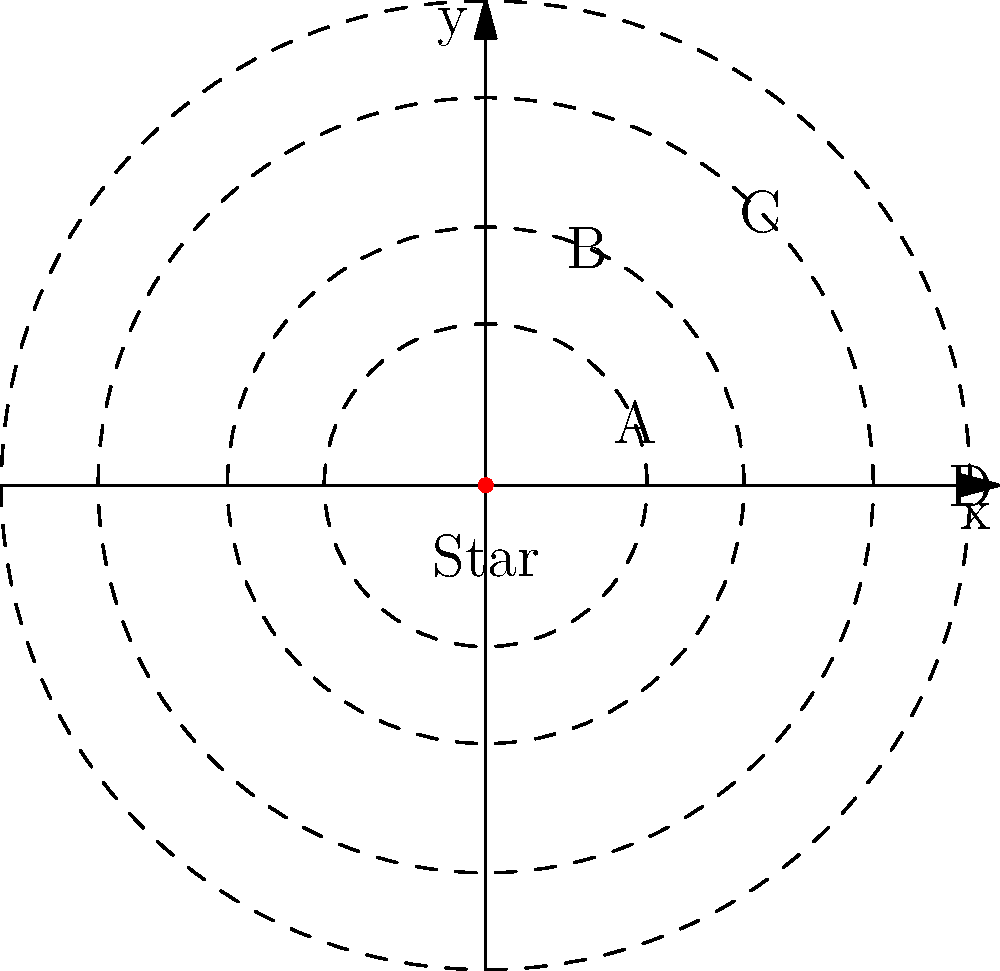In Ben Bova's fictional solar system "Epsilon Eridani," four planets orbit a central star as shown in the diagram. If the orbital period of planet B is 2 Earth years, what would be the approximate orbital period of planet D in Earth years, assuming Kepler's Third Law of Planetary Motion applies? To solve this problem, we'll use Kepler's Third Law of Planetary Motion, which states that the square of the orbital period of a planet is directly proportional to the cube of the semi-major axis of its orbit.

Let's approach this step-by-step:

1) Let $T_B$ and $T_D$ be the orbital periods of planets B and D, respectively.
2) Let $r_B$ and $r_D$ be the orbital radii of planets B and D, respectively.

3) According to Kepler's Third Law:

   $\frac{T_B^2}{r_B^3} = \frac{T_D^2}{r_D^3}$

4) We're given that $T_B = 2$ Earth years.

5) From the diagram, we can estimate that $r_D$ is about 1.875 times $r_B$ (1.5 / 0.8 = 1.875).

6) Substituting these into the equation:

   $\frac{2^2}{r_B^3} = \frac{T_D^2}{(1.875r_B)^3}$

7) Simplifying:

   $\frac{4}{r_B^3} = \frac{T_D^2}{6.59r_B^3}$

8) Solving for $T_D$:

   $T_D^2 = 4 * 6.59 = 26.36$
   $T_D = \sqrt{26.36} \approx 5.13$

Therefore, the orbital period of planet D is approximately 5.13 Earth years.
Answer: 5.13 Earth years 